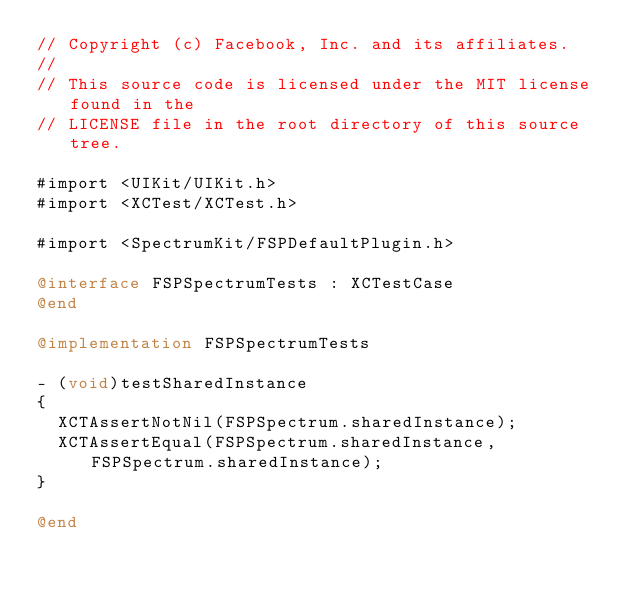Convert code to text. <code><loc_0><loc_0><loc_500><loc_500><_ObjectiveC_>// Copyright (c) Facebook, Inc. and its affiliates.
//
// This source code is licensed under the MIT license found in the
// LICENSE file in the root directory of this source tree.

#import <UIKit/UIKit.h>
#import <XCTest/XCTest.h>

#import <SpectrumKit/FSPDefaultPlugin.h>

@interface FSPSpectrumTests : XCTestCase
@end

@implementation FSPSpectrumTests

- (void)testSharedInstance
{
  XCTAssertNotNil(FSPSpectrum.sharedInstance);
  XCTAssertEqual(FSPSpectrum.sharedInstance, FSPSpectrum.sharedInstance);
}

@end
</code> 